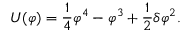<formula> <loc_0><loc_0><loc_500><loc_500>U ( \varphi ) = { \frac { 1 } { 4 } } \varphi ^ { 4 } - \varphi ^ { 3 } + { \frac { 1 } { 2 } } \delta \varphi ^ { 2 } .</formula> 